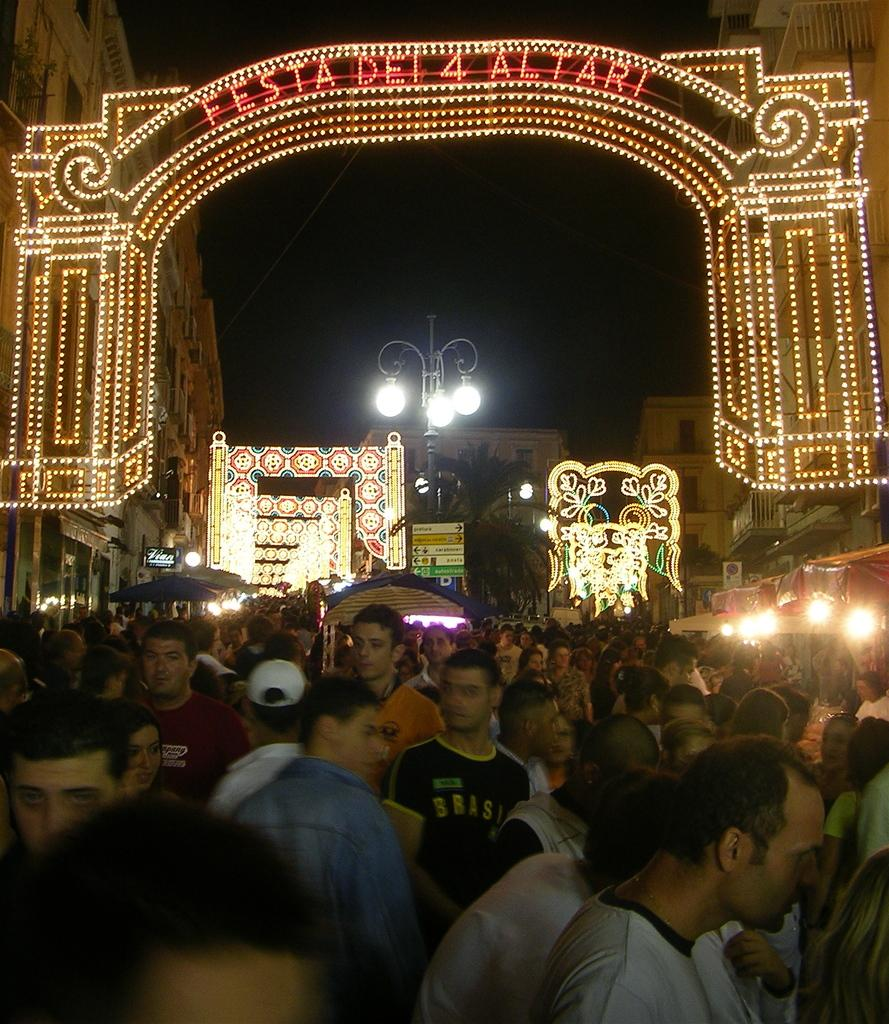What can be seen in the image in terms of human presence? There are people standing in the image. What type of structures are visible in the image? There are buildings visible in the image. What is the source of illumination on the pole in the image? There are lights on a pole in the image. Can you describe the overall lighting conditions in the image? There is lighting in the image. What is the man wearing in the image? A man is wearing a cap in the image. What is the annual income of the organization depicted in the image? There is no organization depicted in the image, so it is not possible to determine its annual income. 